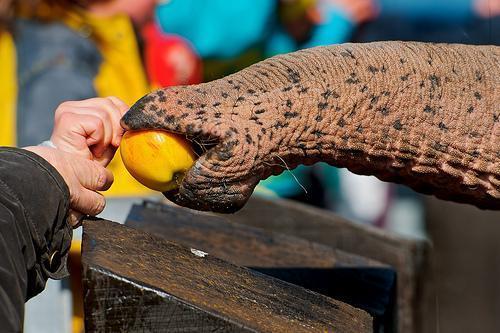How many hands?
Give a very brief answer. 2. 